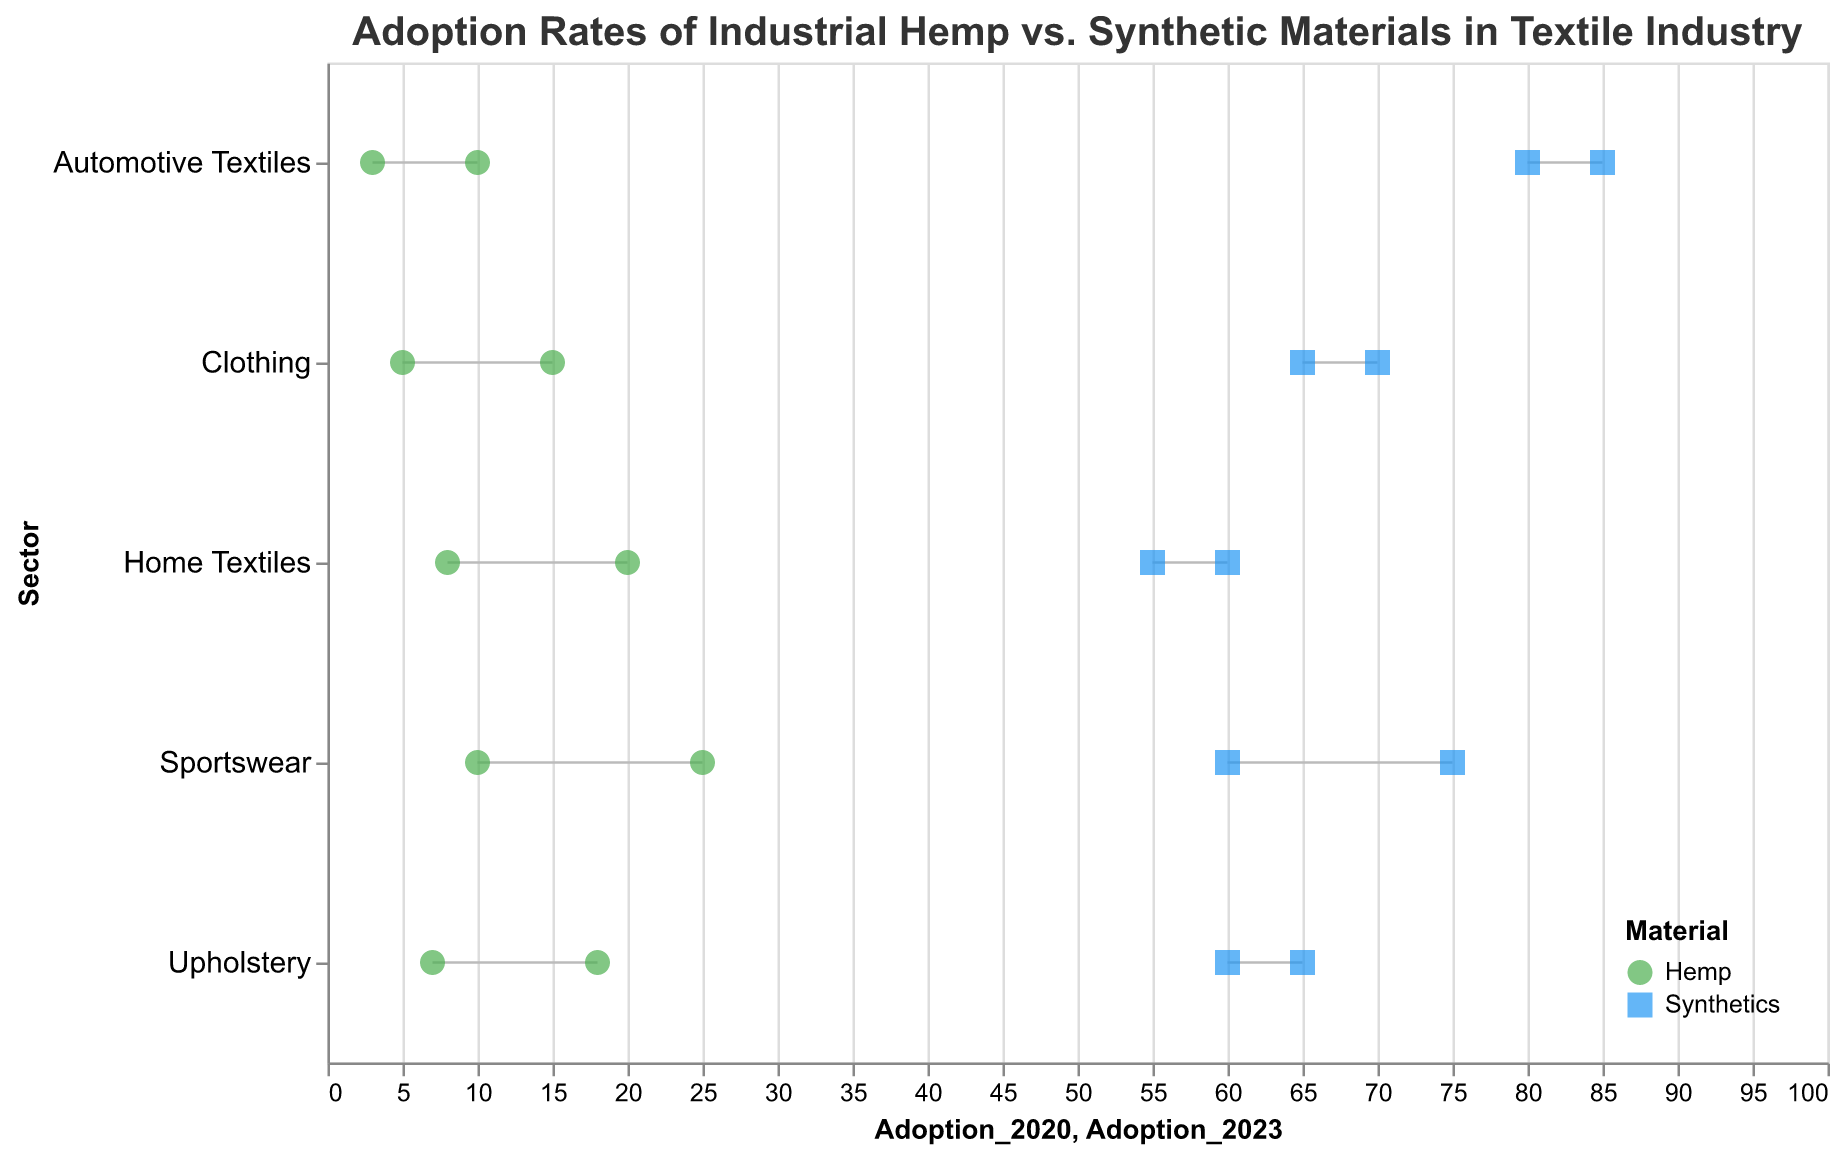What is the adoption rate of hemp in the sportswear sector in 2020 and 2023? The adoption rate of hemp in the sportswear sector in 2020 can be found next to the “Sportswear” sector label represented by a green circle at the 10% mark on the x-axis. Similarly, the adoption rate in 2023 is represented by a green circle at the 25% mark on the x-axis.
Answer: 10% in 2020 and 25% in 2023 How has the adoption of synthetics in the upholstery sector changed from 2020 to 2023? The adoption rate of synthetics in the upholstery sector in 2020 is represented by a blue square at the 65% mark on the x-axis. In 2023, the adoption rate drops to 60%, marked by another blue square. The difference is 65% - 60% = 5%.
Answer: Decreased by 5% Which sector has shown the highest increase in the adoption of hemp from 2020 to 2023? To identify the sector with the highest increase in hemp adoption, compare the differences between 2020 and 2023 adoption rates for each sector. Clothing (10%), Home Textiles (12%), Automotive Textiles (7%), Sportswear (15%), and Upholstery (11%). The largest increase is in the Sportswear sector with a 15% rise.
Answer: Sportswear What is the overall trend in the adoption rate of synthetic materials across all sectors from 2020 to 2023? For each sector, synthetics show a decrease: Clothing (-5%), Home Textiles (-5%), Automotive Textiles (-5%), Sportswear (-15%), and Upholstery (-5%). Therefore, the overall trend for synthetics across all sectors is a decline in adoption.
Answer: Decreasing In the automotive textiles sector, what is the difference in the adoption rate of hemp and synthetics in 2023? In 2023, the adoption rate for hemp in automotive textiles is 10%, and for synthetics, it is 80%. The difference between synthetics and hemp is 80% - 10% = 70%.
Answer: 70% What is the average adoption rate of hemp across all sectors in 2023? The adoption rates of hemp in 2023 are 15%, 20%, 10%, 25%, and 18%. Adding these rates gives a total of 88%, and dividing by 5 sectors gives the average: 88% / 5 = 17.6%.
Answer: 17.6% Which sector experienced the smallest change in the adoption rate of synthetics from 2020 to 2023? The changes in the adoption rates for synthetics are: Clothing (-5%), Home Textiles (-5%), Automotive Textiles (-5%), Sportswear (-15%), and Upholstery (-5%). The smallest change, a -5% reduction, is seen in multiple sectors—Clothing, Home Textiles, Automotive Textiles, and Upholstery.
Answer: Clothing, Home Textiles, Automotive Textiles, and Upholstery Between 2020 and 2023, has any sector shown a decrease in the adoption rate of hemp? By examining each sector, we see that hemp adoption increased in all sectors: Clothing (+10%), Home Textiles (+12%), Automotive Textiles (+7%), Sportswear (+15%), and Upholstery (+11%). No sector shows a decrease in hemp adoption.
Answer: No What is the combined adoption rate of synthetics in the home textiles and sportswear sectors in 2023? The adoption rate of synthetics in home textiles in 2023 is 55%, and in sportswear, it is 60%. Adding these gives the combined rate: 55% + 60% = 115%.
Answer: 115% 